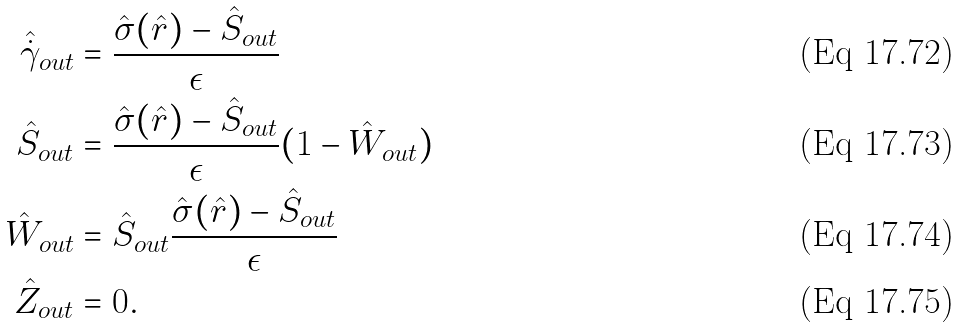Convert formula to latex. <formula><loc_0><loc_0><loc_500><loc_500>\hat { \dot { \gamma } } _ { o u t } & = \frac { \hat { \sigma } ( \hat { r } ) - { \hat { S } } _ { o u t } } { \epsilon } \\ { \hat { S } } _ { o u t } & = \frac { \hat { \sigma } ( \hat { r } ) - { \hat { S } } _ { o u t } } { \epsilon } ( 1 - { \hat { W } } _ { o u t } ) \\ { \hat { W } } _ { o u t } & = { \hat { S } } _ { o u t } \frac { \hat { \sigma } ( \hat { r } ) - { \hat { S } } _ { o u t } } { \epsilon } \\ { \hat { Z } } _ { o u t } & = 0 .</formula> 